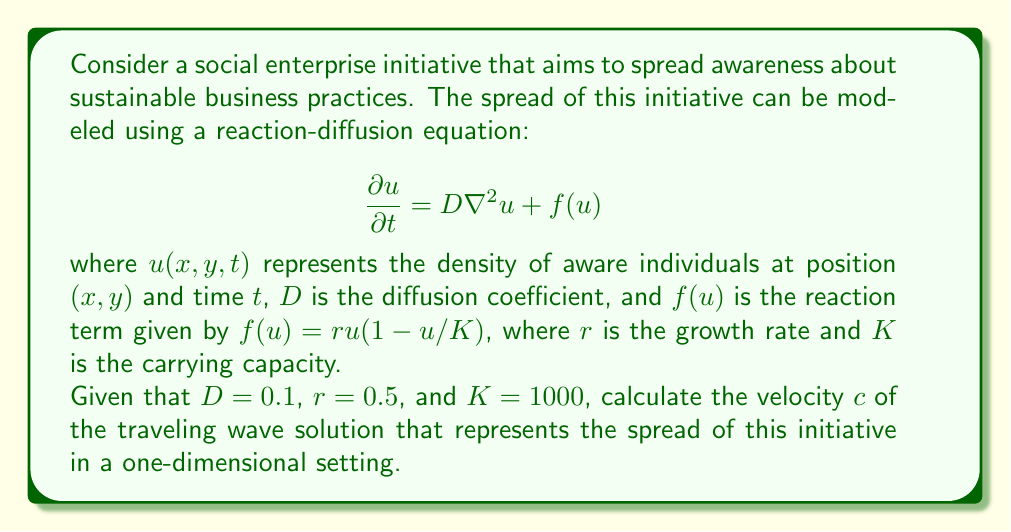Teach me how to tackle this problem. To solve this problem, we need to use the Fisher-KPP equation, which is a special case of the reaction-diffusion equation for population dynamics. In a one-dimensional setting, the equation becomes:

$$\frac{\partial u}{\partial t} = D\frac{\partial^2u}{\partial x^2} + ru(1-u/K)$$

For traveling wave solutions, there's a well-known result that relates the velocity of the wave to the parameters of the equation. The minimum wave speed (which is typically the one observed in nature) is given by:

$$c = 2\sqrt{rD}$$

This formula comes from a linear analysis of the leading edge of the wave, where $u$ is small.

Given:
$D = 0.1$ (diffusion coefficient)
$r = 0.5$ (growth rate)
$K = 1000$ (carrying capacity)

Note that $K$ doesn't appear in the formula for wave speed, as it only affects the height of the wave, not its speed.

Substituting the values into the formula:

$$c = 2\sqrt{0.5 \cdot 0.1}$$

$$c = 2\sqrt{0.05}$$

$$c = 2 \cdot \sqrt{0.05}$$

$$c = 2 \cdot 0.2236$$

$$c \approx 0.4472$$

This result represents the speed at which the awareness of sustainable business practices spreads through the population in this model.
Answer: The velocity of the traveling wave solution is approximately 0.4472 units of distance per unit of time. 